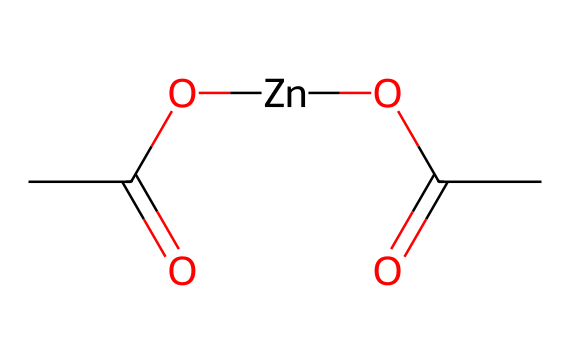What is the central metal atom in zinc acetate? The chemical structure shows that there is a central atom labeled Zn, which represents zinc.
Answer: zinc How many acetate groups are attached to the zinc atom? The structure indicates that there are two OC(C)=O groups, which corresponds to two acetate groups linked to the zinc atom.
Answer: 2 What type of compound is zinc acetate classified as? Zinc acetate is an ionic compound formed from the combination of zinc ions and acetate ions, characteristic of electrolytes.
Answer: electrolyte What is the molecular formula of zinc acetate? Based on the structure, the metal zinc (Zn) is combined with two acetate units (C4H6O4), resulting in the molecular formula Zn(C2H3O2)2.
Answer: Zn(C2H3O2)2 How does zinc acetate contribute to immune function? Zinc ions can help regulate immune function, promoting the activity of immune cells, which is fundamental for physically active individuals.
Answer: Zinc ions What type of bonds are present in zinc acetate? The structure reveals coordination bonds between the zinc atom and the acetate groups, as well as covalent bonds within each acetate group.
Answer: coordination and covalent bonds 